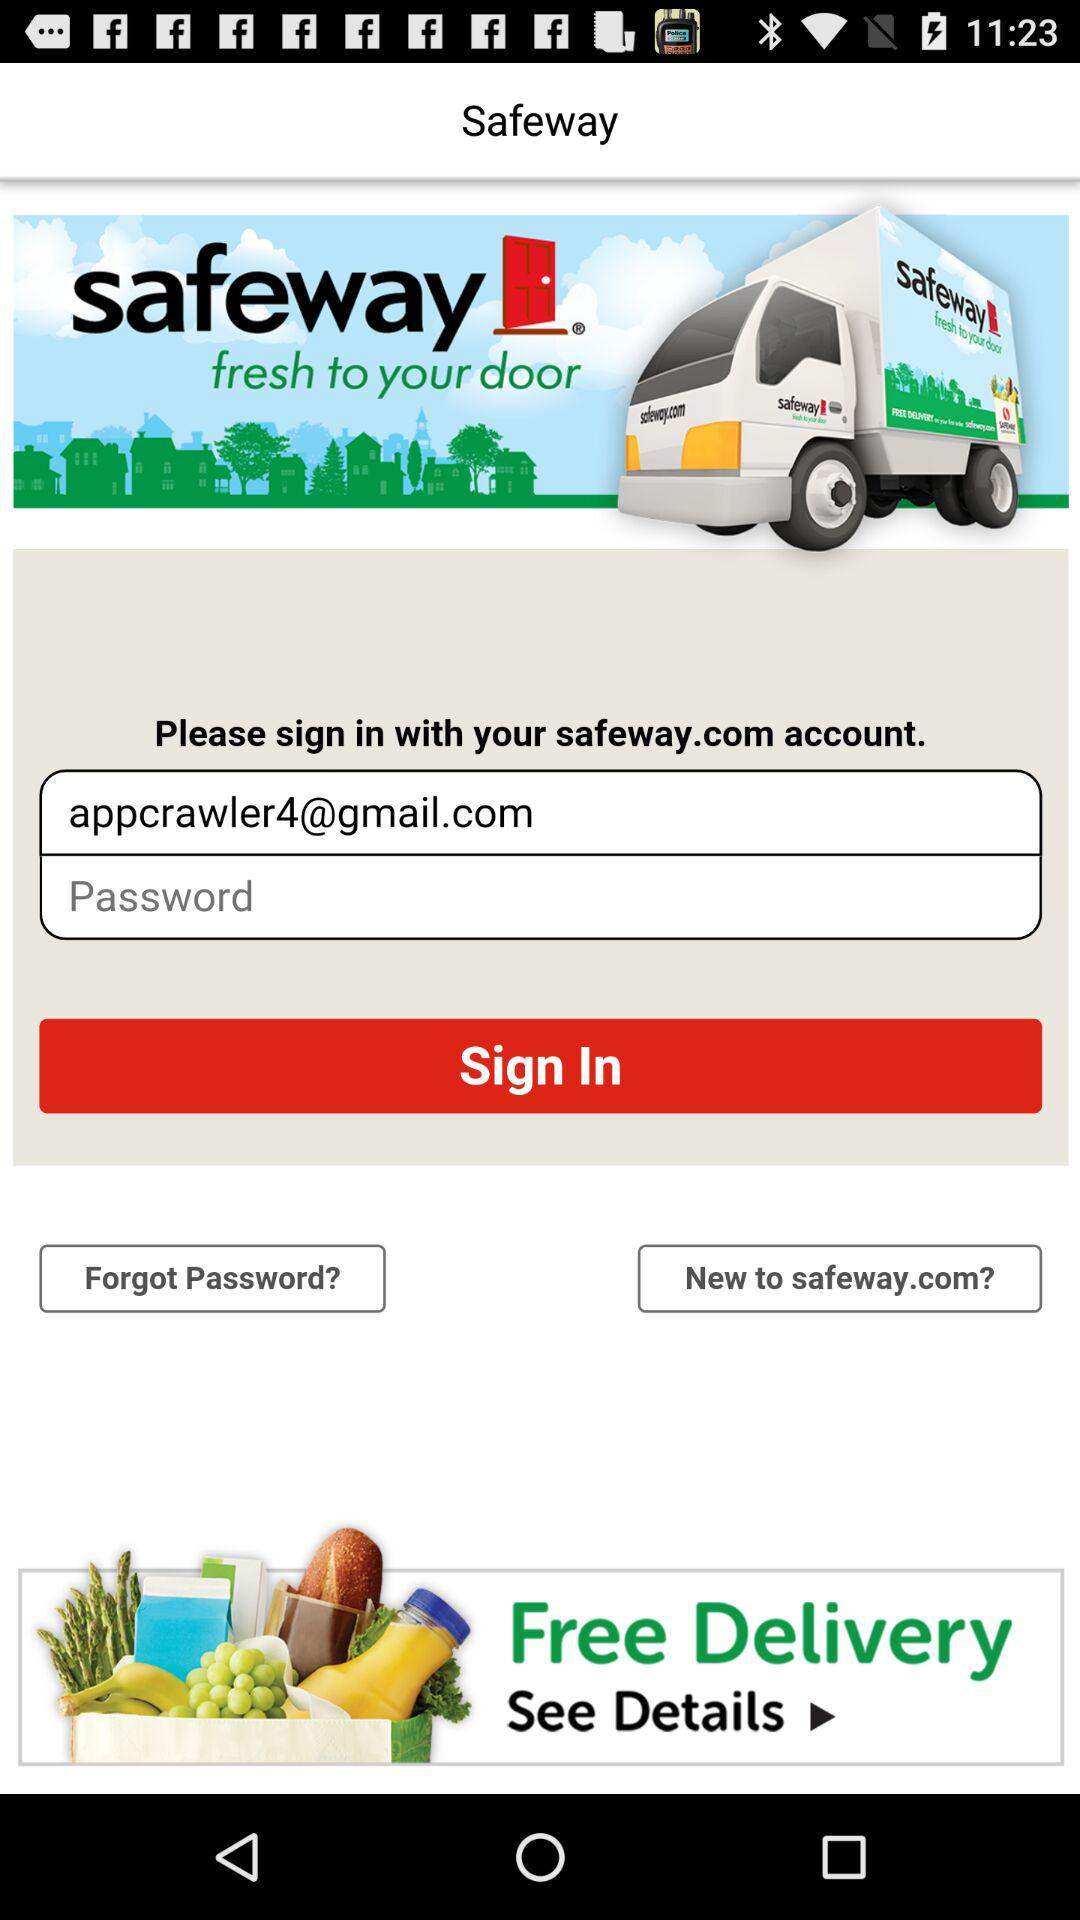How many text inputs are on the screen?
Answer the question using a single word or phrase. 2 